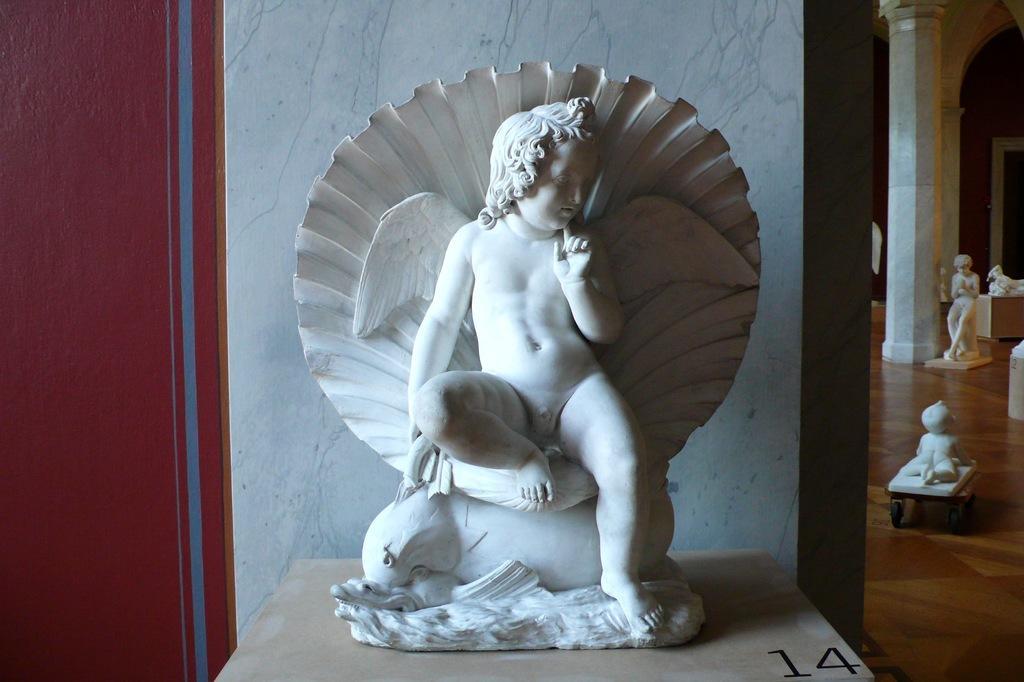How would you summarize this image in a sentence or two? In this image we can see the statues on the floor and we can see the other statue on the table near the wall. We can see there are pillars and red color object. 